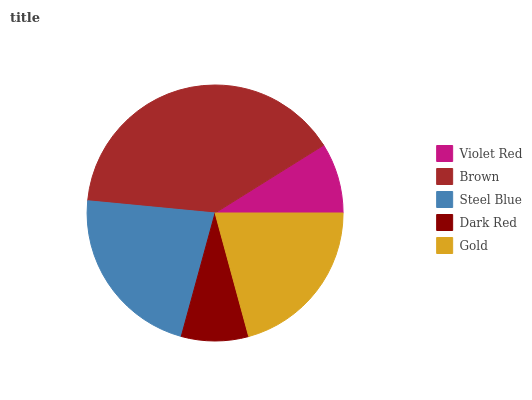Is Dark Red the minimum?
Answer yes or no. Yes. Is Brown the maximum?
Answer yes or no. Yes. Is Steel Blue the minimum?
Answer yes or no. No. Is Steel Blue the maximum?
Answer yes or no. No. Is Brown greater than Steel Blue?
Answer yes or no. Yes. Is Steel Blue less than Brown?
Answer yes or no. Yes. Is Steel Blue greater than Brown?
Answer yes or no. No. Is Brown less than Steel Blue?
Answer yes or no. No. Is Gold the high median?
Answer yes or no. Yes. Is Gold the low median?
Answer yes or no. Yes. Is Steel Blue the high median?
Answer yes or no. No. Is Brown the low median?
Answer yes or no. No. 